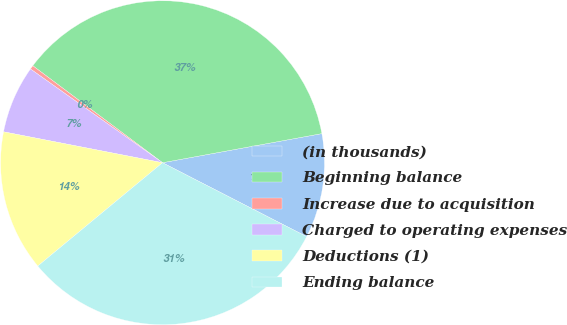Convert chart. <chart><loc_0><loc_0><loc_500><loc_500><pie_chart><fcel>(in thousands)<fcel>Beginning balance<fcel>Increase due to acquisition<fcel>Charged to operating expenses<fcel>Deductions (1)<fcel>Ending balance<nl><fcel>10.42%<fcel>36.91%<fcel>0.39%<fcel>6.77%<fcel>14.07%<fcel>31.45%<nl></chart> 